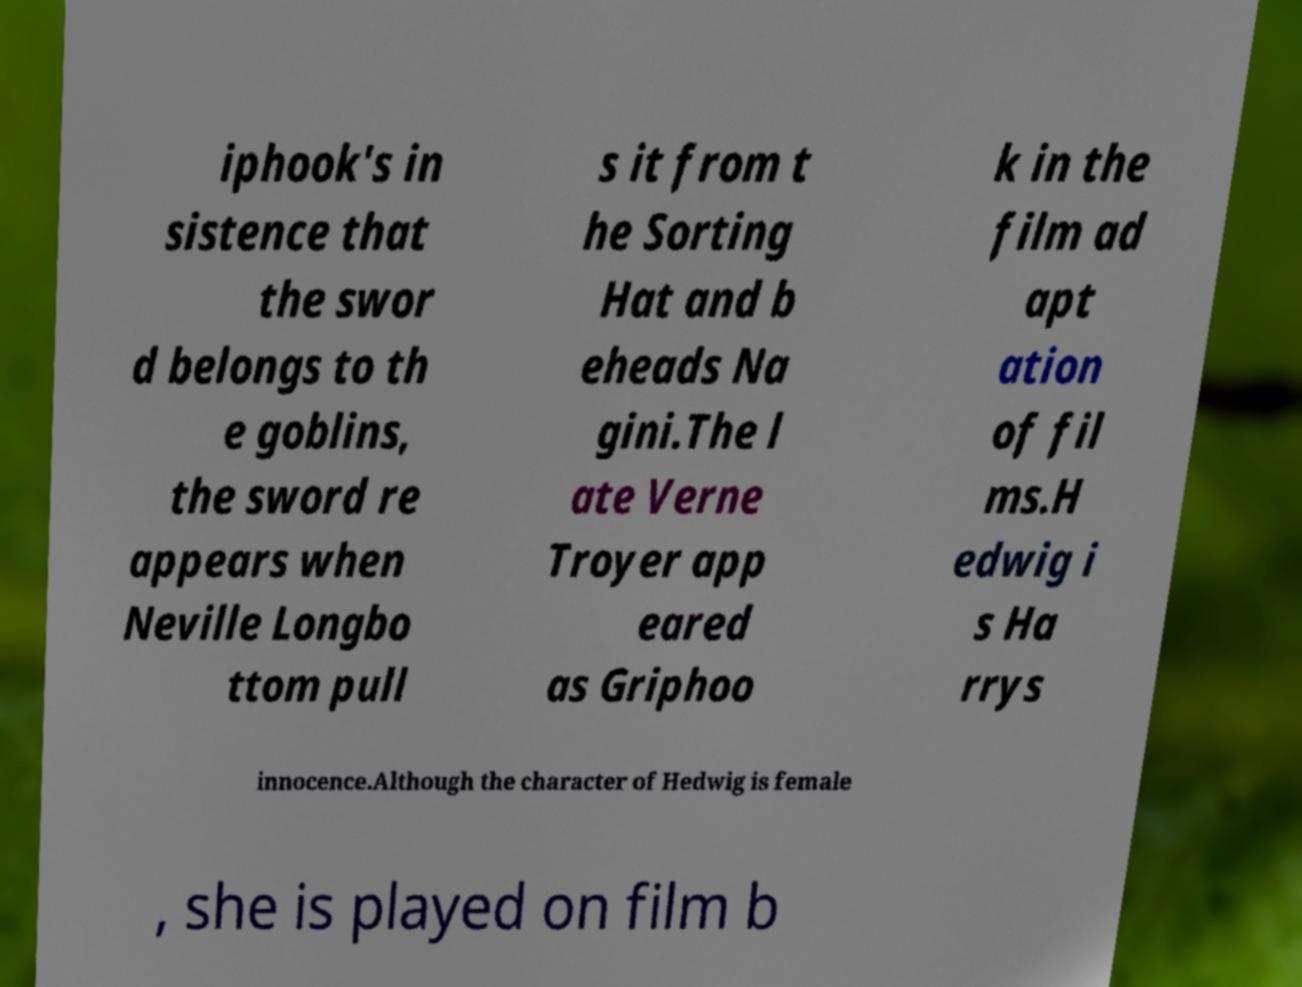What messages or text are displayed in this image? I need them in a readable, typed format. iphook's in sistence that the swor d belongs to th e goblins, the sword re appears when Neville Longbo ttom pull s it from t he Sorting Hat and b eheads Na gini.The l ate Verne Troyer app eared as Griphoo k in the film ad apt ation of fil ms.H edwig i s Ha rrys innocence.Although the character of Hedwig is female , she is played on film b 